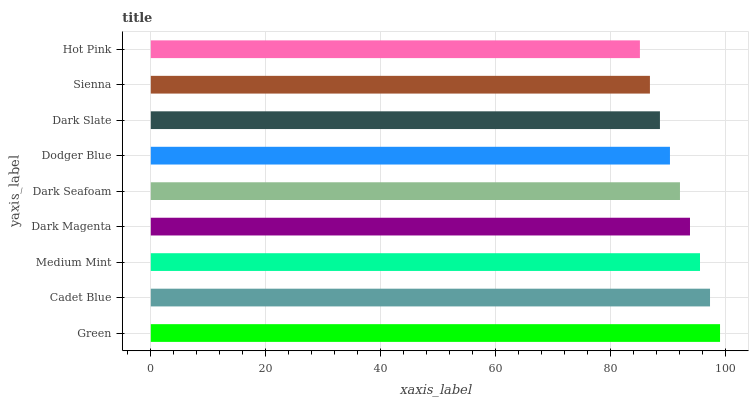Is Hot Pink the minimum?
Answer yes or no. Yes. Is Green the maximum?
Answer yes or no. Yes. Is Cadet Blue the minimum?
Answer yes or no. No. Is Cadet Blue the maximum?
Answer yes or no. No. Is Green greater than Cadet Blue?
Answer yes or no. Yes. Is Cadet Blue less than Green?
Answer yes or no. Yes. Is Cadet Blue greater than Green?
Answer yes or no. No. Is Green less than Cadet Blue?
Answer yes or no. No. Is Dark Seafoam the high median?
Answer yes or no. Yes. Is Dark Seafoam the low median?
Answer yes or no. Yes. Is Dark Slate the high median?
Answer yes or no. No. Is Dark Magenta the low median?
Answer yes or no. No. 